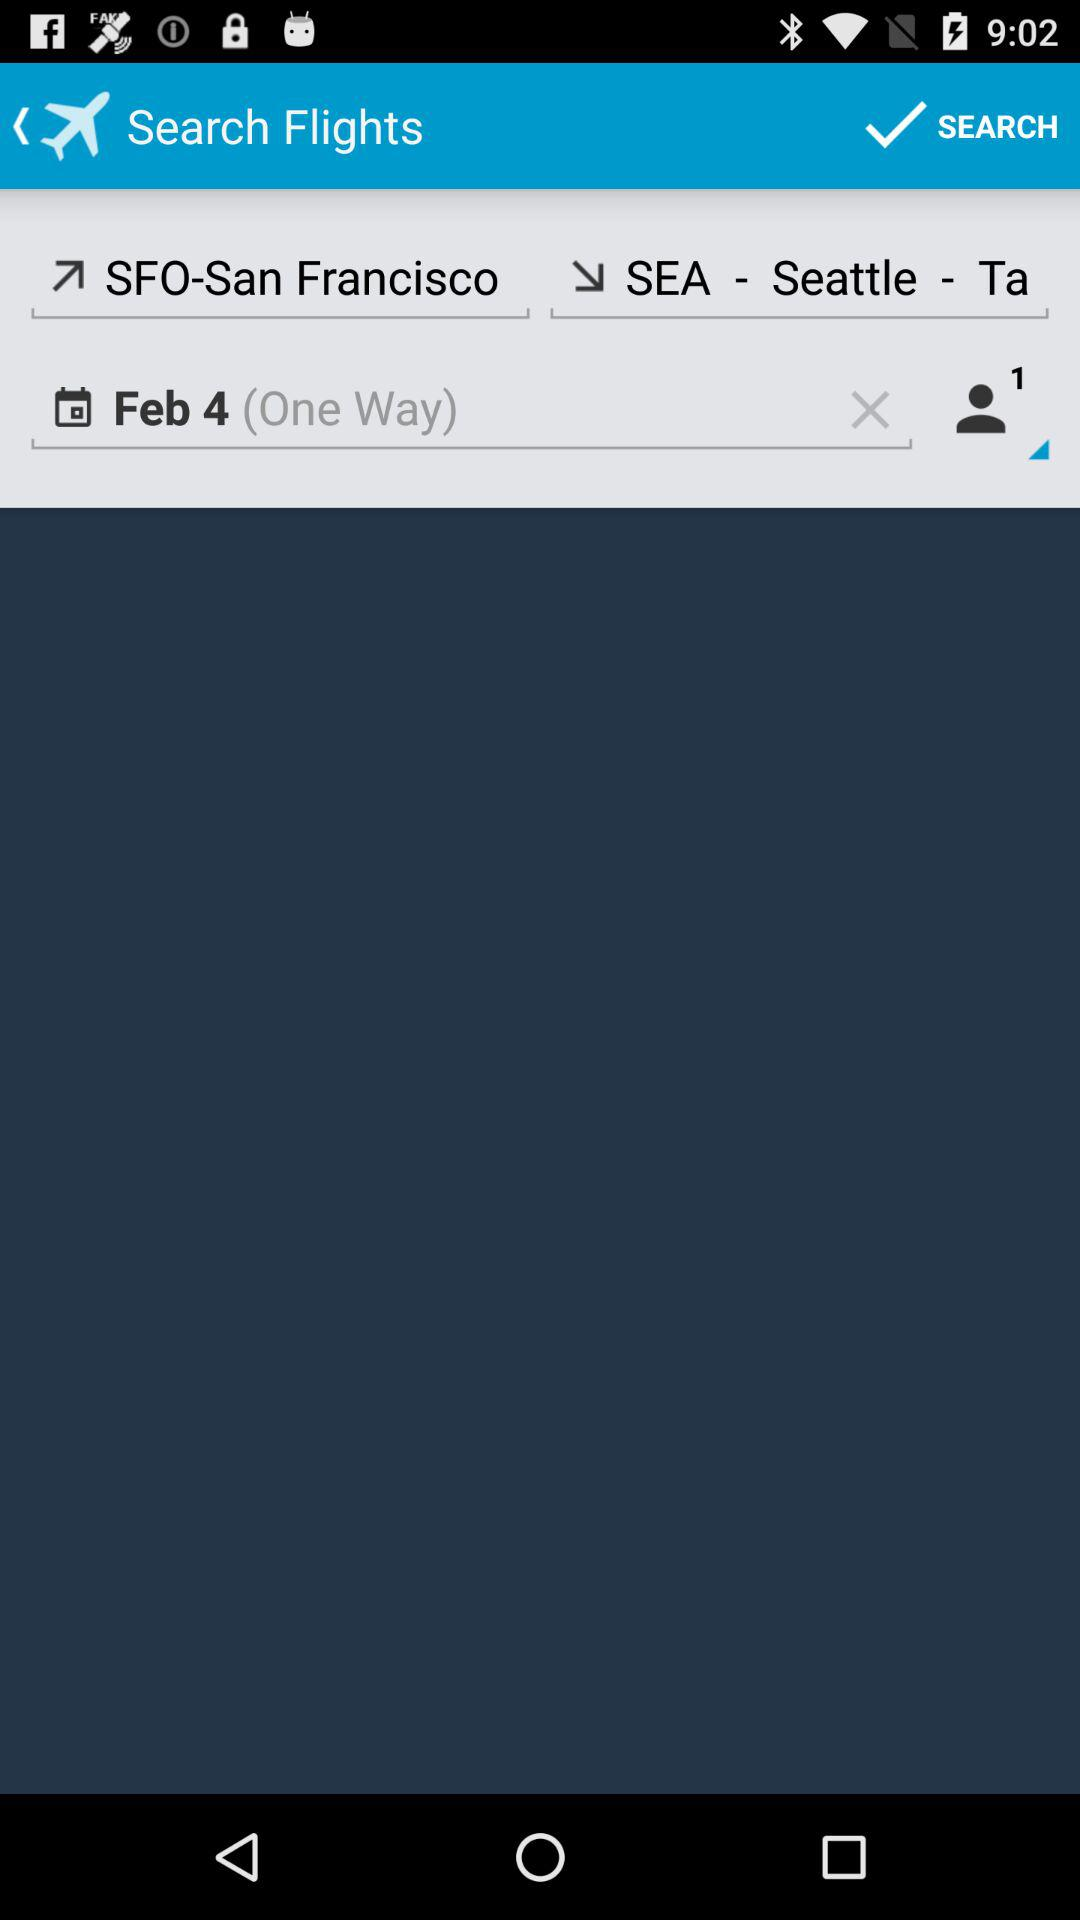What is the date? The date is February 4. 